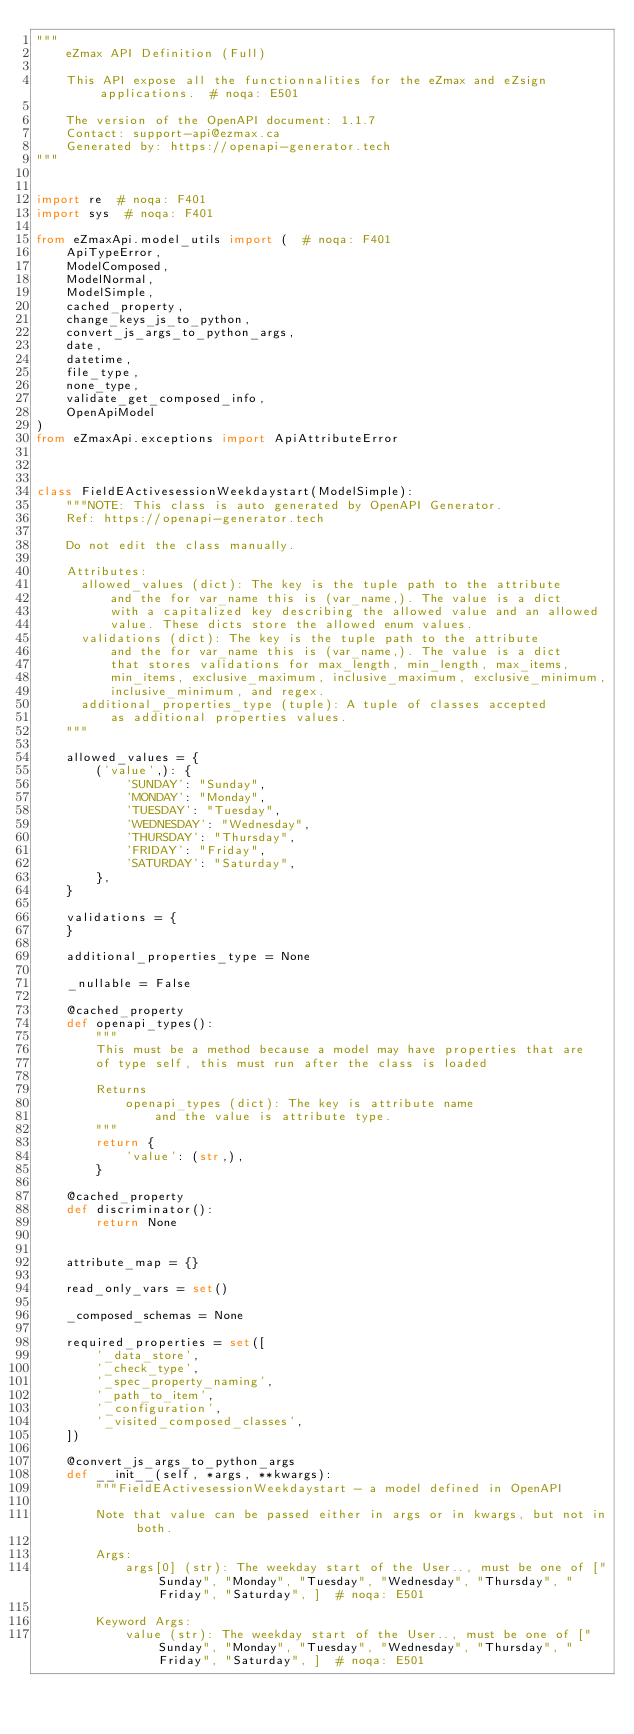<code> <loc_0><loc_0><loc_500><loc_500><_Python_>"""
    eZmax API Definition (Full)

    This API expose all the functionnalities for the eZmax and eZsign applications.  # noqa: E501

    The version of the OpenAPI document: 1.1.7
    Contact: support-api@ezmax.ca
    Generated by: https://openapi-generator.tech
"""


import re  # noqa: F401
import sys  # noqa: F401

from eZmaxApi.model_utils import (  # noqa: F401
    ApiTypeError,
    ModelComposed,
    ModelNormal,
    ModelSimple,
    cached_property,
    change_keys_js_to_python,
    convert_js_args_to_python_args,
    date,
    datetime,
    file_type,
    none_type,
    validate_get_composed_info,
    OpenApiModel
)
from eZmaxApi.exceptions import ApiAttributeError



class FieldEActivesessionWeekdaystart(ModelSimple):
    """NOTE: This class is auto generated by OpenAPI Generator.
    Ref: https://openapi-generator.tech

    Do not edit the class manually.

    Attributes:
      allowed_values (dict): The key is the tuple path to the attribute
          and the for var_name this is (var_name,). The value is a dict
          with a capitalized key describing the allowed value and an allowed
          value. These dicts store the allowed enum values.
      validations (dict): The key is the tuple path to the attribute
          and the for var_name this is (var_name,). The value is a dict
          that stores validations for max_length, min_length, max_items,
          min_items, exclusive_maximum, inclusive_maximum, exclusive_minimum,
          inclusive_minimum, and regex.
      additional_properties_type (tuple): A tuple of classes accepted
          as additional properties values.
    """

    allowed_values = {
        ('value',): {
            'SUNDAY': "Sunday",
            'MONDAY': "Monday",
            'TUESDAY': "Tuesday",
            'WEDNESDAY': "Wednesday",
            'THURSDAY': "Thursday",
            'FRIDAY': "Friday",
            'SATURDAY': "Saturday",
        },
    }

    validations = {
    }

    additional_properties_type = None

    _nullable = False

    @cached_property
    def openapi_types():
        """
        This must be a method because a model may have properties that are
        of type self, this must run after the class is loaded

        Returns
            openapi_types (dict): The key is attribute name
                and the value is attribute type.
        """
        return {
            'value': (str,),
        }

    @cached_property
    def discriminator():
        return None


    attribute_map = {}

    read_only_vars = set()

    _composed_schemas = None

    required_properties = set([
        '_data_store',
        '_check_type',
        '_spec_property_naming',
        '_path_to_item',
        '_configuration',
        '_visited_composed_classes',
    ])

    @convert_js_args_to_python_args
    def __init__(self, *args, **kwargs):
        """FieldEActivesessionWeekdaystart - a model defined in OpenAPI

        Note that value can be passed either in args or in kwargs, but not in both.

        Args:
            args[0] (str): The weekday start of the User.., must be one of ["Sunday", "Monday", "Tuesday", "Wednesday", "Thursday", "Friday", "Saturday", ]  # noqa: E501

        Keyword Args:
            value (str): The weekday start of the User.., must be one of ["Sunday", "Monday", "Tuesday", "Wednesday", "Thursday", "Friday", "Saturday", ]  # noqa: E501</code> 